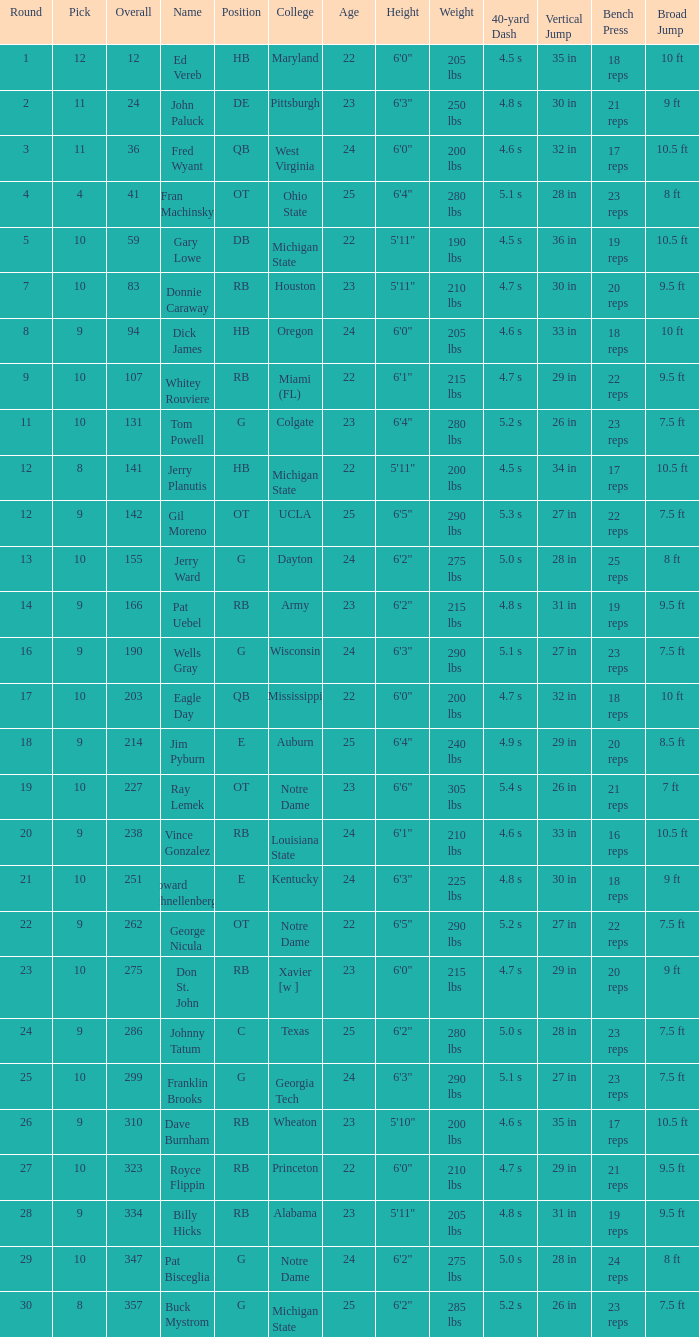What is the highest overall pick number for george nicula who had a pick smaller than 9? None. 